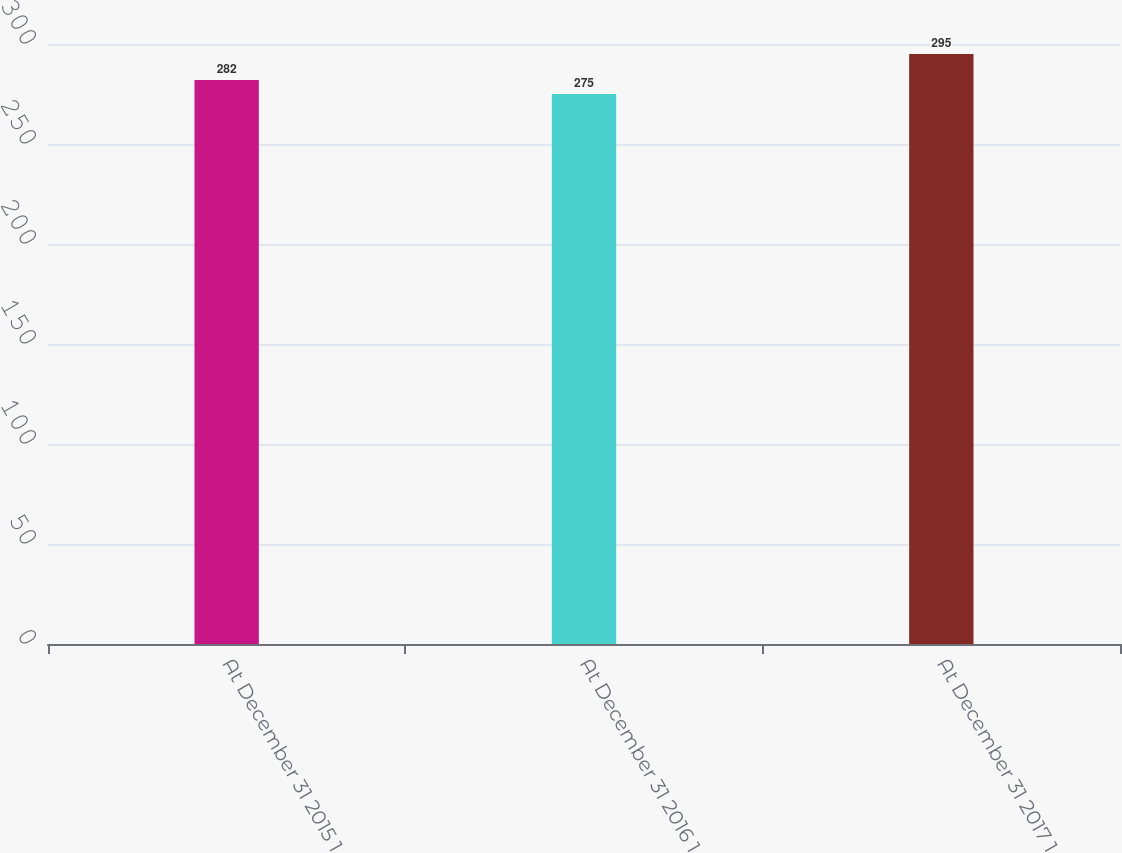Convert chart. <chart><loc_0><loc_0><loc_500><loc_500><bar_chart><fcel>At December 31 2015 1<fcel>At December 31 2016 1<fcel>At December 31 2017 1<nl><fcel>282<fcel>275<fcel>295<nl></chart> 